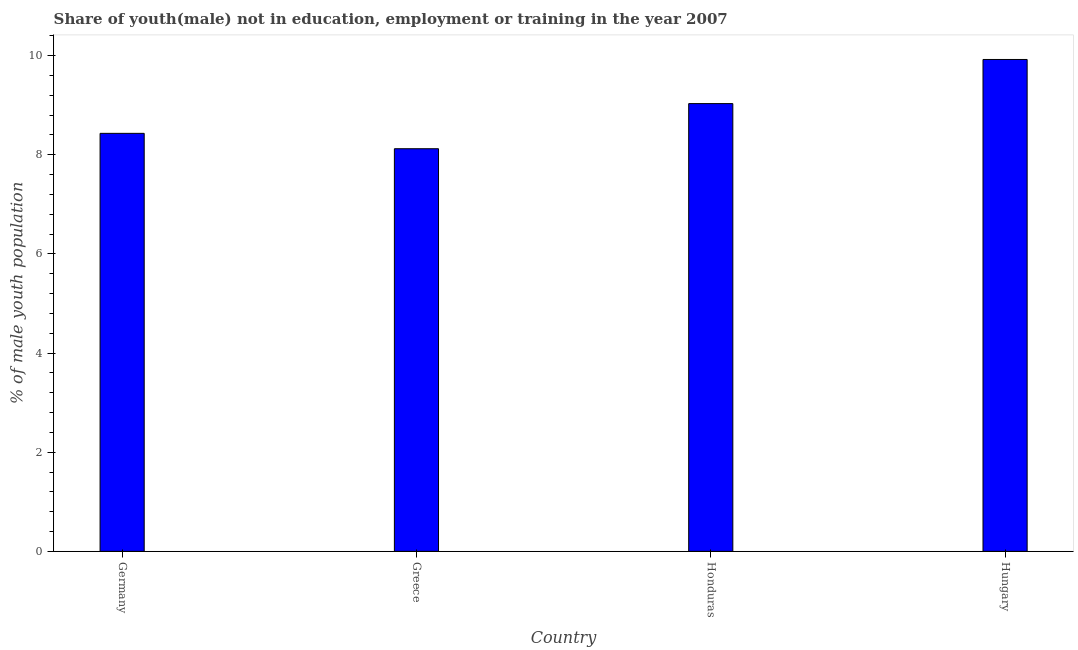Does the graph contain grids?
Give a very brief answer. No. What is the title of the graph?
Your response must be concise. Share of youth(male) not in education, employment or training in the year 2007. What is the label or title of the Y-axis?
Your answer should be very brief. % of male youth population. What is the unemployed male youth population in Honduras?
Your answer should be very brief. 9.03. Across all countries, what is the maximum unemployed male youth population?
Your response must be concise. 9.92. Across all countries, what is the minimum unemployed male youth population?
Offer a very short reply. 8.12. In which country was the unemployed male youth population maximum?
Keep it short and to the point. Hungary. In which country was the unemployed male youth population minimum?
Provide a succinct answer. Greece. What is the sum of the unemployed male youth population?
Your answer should be very brief. 35.5. What is the difference between the unemployed male youth population in Germany and Honduras?
Your response must be concise. -0.6. What is the average unemployed male youth population per country?
Provide a short and direct response. 8.88. What is the median unemployed male youth population?
Give a very brief answer. 8.73. In how many countries, is the unemployed male youth population greater than 2.4 %?
Offer a terse response. 4. What is the ratio of the unemployed male youth population in Germany to that in Greece?
Keep it short and to the point. 1.04. Is the unemployed male youth population in Germany less than that in Greece?
Ensure brevity in your answer.  No. What is the difference between the highest and the second highest unemployed male youth population?
Provide a succinct answer. 0.89. Is the sum of the unemployed male youth population in Honduras and Hungary greater than the maximum unemployed male youth population across all countries?
Offer a terse response. Yes. What is the difference between the highest and the lowest unemployed male youth population?
Ensure brevity in your answer.  1.8. In how many countries, is the unemployed male youth population greater than the average unemployed male youth population taken over all countries?
Offer a terse response. 2. How many bars are there?
Your answer should be compact. 4. Are all the bars in the graph horizontal?
Offer a very short reply. No. Are the values on the major ticks of Y-axis written in scientific E-notation?
Offer a very short reply. No. What is the % of male youth population in Germany?
Make the answer very short. 8.43. What is the % of male youth population in Greece?
Offer a terse response. 8.12. What is the % of male youth population of Honduras?
Your response must be concise. 9.03. What is the % of male youth population in Hungary?
Your answer should be very brief. 9.92. What is the difference between the % of male youth population in Germany and Greece?
Make the answer very short. 0.31. What is the difference between the % of male youth population in Germany and Honduras?
Provide a short and direct response. -0.6. What is the difference between the % of male youth population in Germany and Hungary?
Your response must be concise. -1.49. What is the difference between the % of male youth population in Greece and Honduras?
Your response must be concise. -0.91. What is the difference between the % of male youth population in Greece and Hungary?
Keep it short and to the point. -1.8. What is the difference between the % of male youth population in Honduras and Hungary?
Make the answer very short. -0.89. What is the ratio of the % of male youth population in Germany to that in Greece?
Provide a short and direct response. 1.04. What is the ratio of the % of male youth population in Germany to that in Honduras?
Offer a very short reply. 0.93. What is the ratio of the % of male youth population in Greece to that in Honduras?
Make the answer very short. 0.9. What is the ratio of the % of male youth population in Greece to that in Hungary?
Make the answer very short. 0.82. What is the ratio of the % of male youth population in Honduras to that in Hungary?
Your answer should be compact. 0.91. 